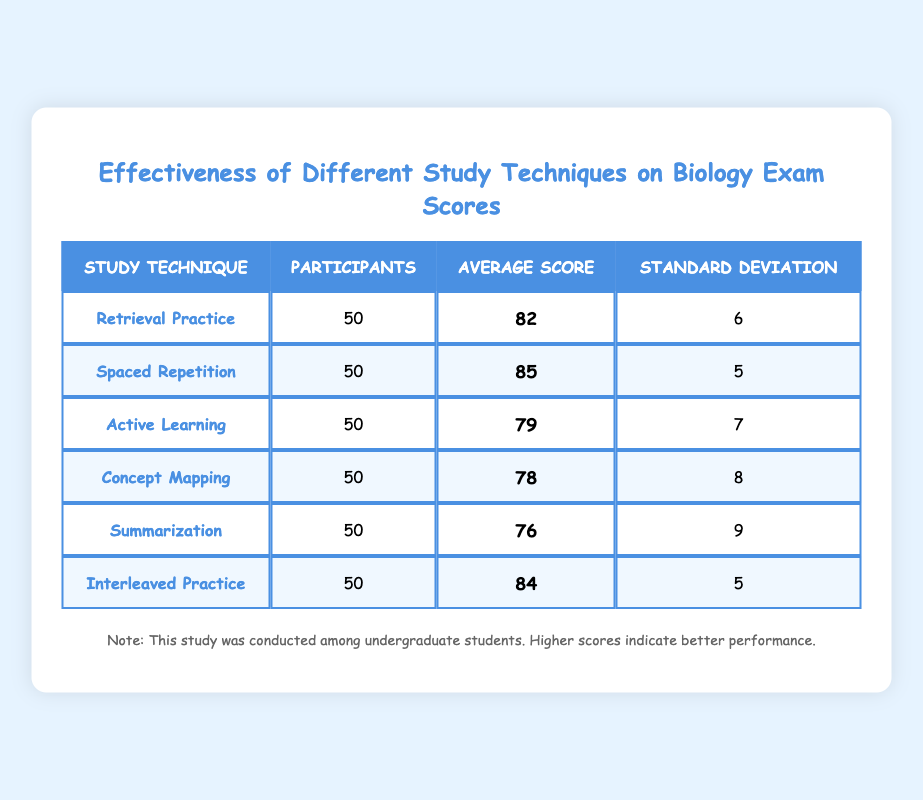What is the average score for the Spaced Repetition technique? According to the table, the average score for the Spaced Repetition technique is listed directly as 85.
Answer: 85 How many participants were involved in the study for the Concept Mapping technique? The table indicates that there were 50 participants involved in the study for the Concept Mapping technique.
Answer: 50 What is the standard deviation of the Active Learning technique? The standard deviation for the Active Learning technique is provided in the table as 7.
Answer: 7 Which study technique had the highest average score? By comparing the average scores listed in the table, Spaced Repetition has the highest average score of 85, making it the most effective technique in this study.
Answer: Spaced Repetition If you were to calculate the average score of Retrieval Practice and Interleaved Practice, what would it be? The average scores for Retrieval Practice and Interleaved Practice are 82 and 84, respectively. Adding these scores gives 166, and dividing by 2 (since there are two techniques) results in an average score of 83.
Answer: 83 Is the Summarization technique more effective than Active Learning based on the average scores? The average score for Summarization is 76, while Active Learning has an average score of 79. Since 76 is less than 79, Summarization is not more effective than Active Learning.
Answer: No What is the difference in average scores between the highest and lowest techniques? The highest average score is 85 (Spaced Repetition) and the lowest is 76 (Summarization). The difference is calculated as 85 - 76 = 9.
Answer: 9 Which study technique had the lowest standard deviation, and what is its value? By inspecting the table, the Interleaved Practice and Spaced Repetition techniques both have the lowest standard deviation of 5.
Answer: Interleaved Practice, 5 Is there a technique that has the same number of participants as the others? All techniques listed in the table have the same number of participants, which is 50 for each of them.
Answer: Yes 